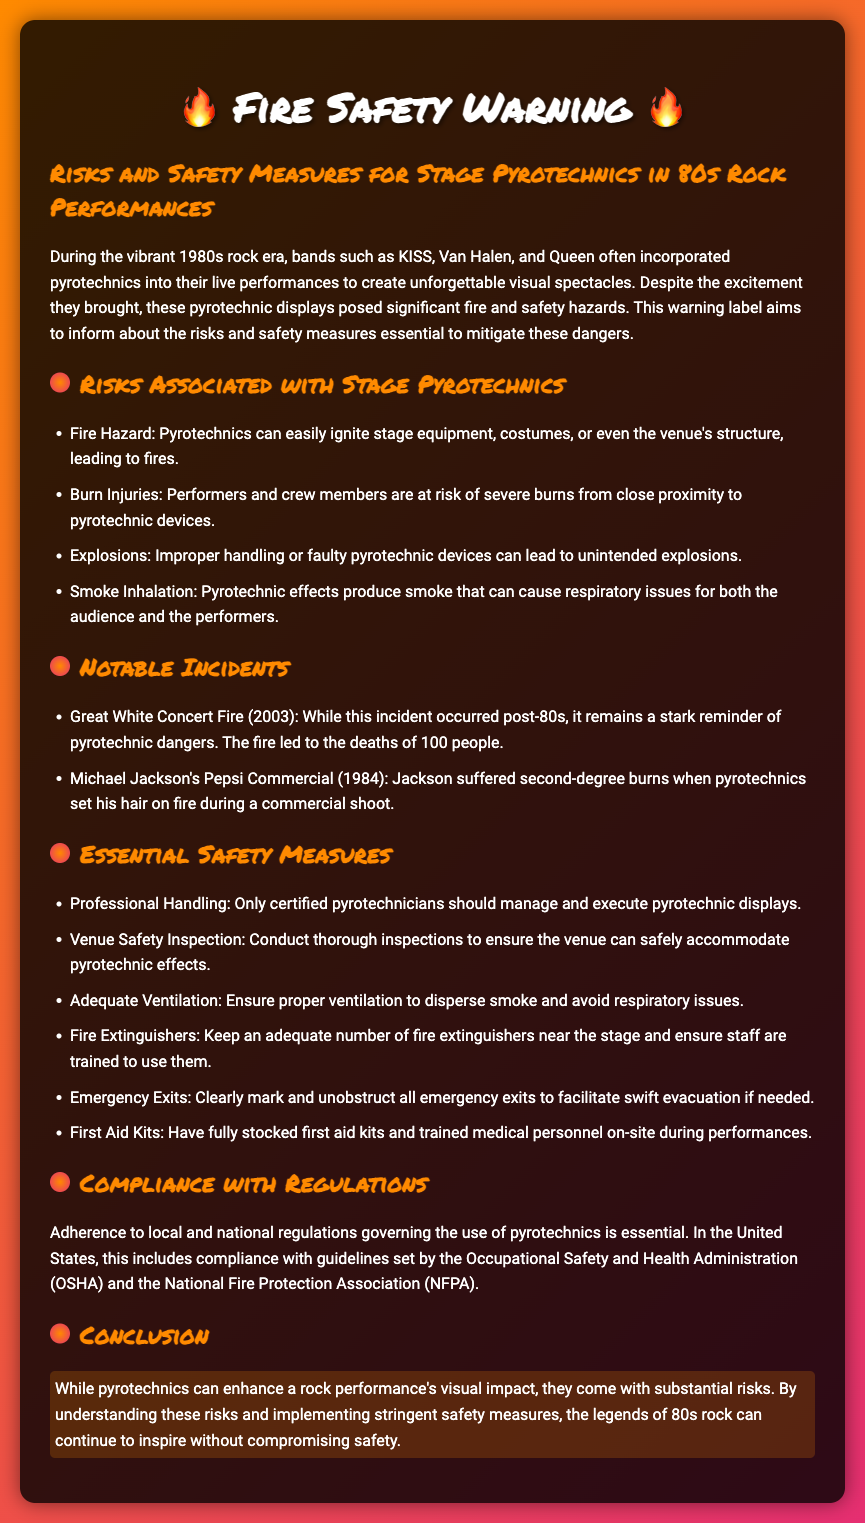What is the title of the document? The title of the document is included in the HTML title tag, which is "Fire Safety Warning: 80s Rock Pyrotechnics."
Answer: Fire Safety Warning: 80s Rock Pyrotechnics Who were mentioned as bands using pyrotechnics? The document lists specific bands known for pyrotechnics, such as KISS, Van Halen, and Queen.
Answer: KISS, Van Halen, Queen What year did the Michael Jackson Pepsi commercial incident occur? The document states that the incident took place in 1984.
Answer: 1984 What is one major fire hazard associated with pyrotechnics? The document lists fire hazards including the ignition of stage equipment, costumes, or the venue's structure.
Answer: Fire Hazard What is the total number of essential safety measures listed? The document outlines a total of six essential safety measures to follow when using pyrotechnics.
Answer: Six Which organization’s regulations must be complied with? The document mentions the Occupational Safety and Health Administration (OSHA) and the National Fire Protection Association (NFPA) as regulatory bodies.
Answer: OSHA and NFPA What type of incidents does the Great White Concert relate to? The document classifies the Great White Concert incident as a notable incident related to pyrotechnics, highlighting the potential dangers.
Answer: Notable incidents What does the flame icon represent in the document? The flame icon is used as a visual cue to emphasize sections discussing risks and safety measures related to pyrotechnics.
Answer: Risks and Safety Measures 